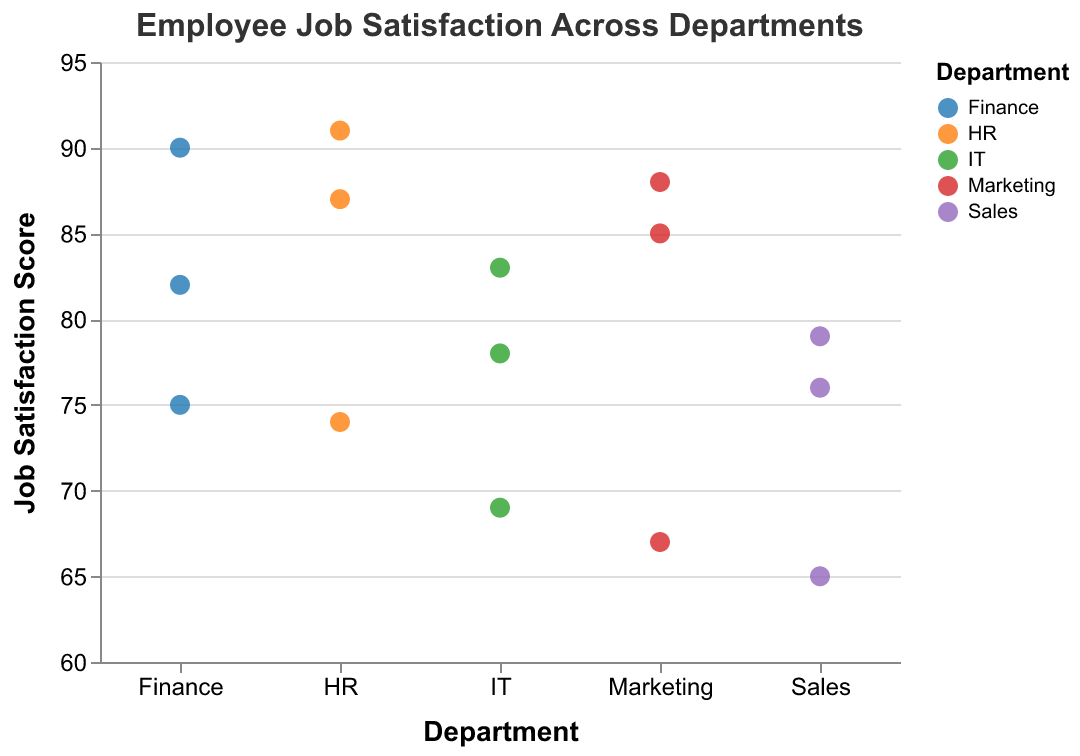What's the title of the figure? The title is located at the top of the plot and reads "Employee Job Satisfaction Across Departments."
Answer: Employee Job Satisfaction Across Departments What are the departments listed along the x-axis? The x-axis lists the departments in a nominal fashion. The departments are Finance, Marketing, IT, HR, and Sales.
Answer: Finance, Marketing, IT, HR, Sales How many employees are there in the IT department? By counting the data points associated with the IT department, there are three employees in IT.
Answer: Three (3) Which department has the highest job satisfaction score, and what is the score? By looking for the highest data point in the y-axis and checking its corresponding department on the x-axis, it can be observed that the HR department has the highest score of 91.
Answer: HR, 91 What is the average job satisfaction score in the Sales department? Summing the job satisfaction scores for the Sales department: 76, 79, and 65, gives a total of 220. Dividing by the number of employees (3) results in an average score of 73.33.
Answer: 73.33 Which employee in the Marketing department has the lowest job satisfaction score? By identifying the lowest point within the Marketing department's data points on the y-axis, it's James Brown with a score of 67.
Answer: James Brown How does the average job satisfaction score of the Finance department compare to that of the HR department? First, calculate the average for the Finance (82, 75, 90) which is (82+75+90)/3 = 82.33. For HR (87, 74, 91) it is (87+74+91)/3 = 84. The HR department's average score (84) is higher than that of the Finance department (82.33).
Answer: HR is higher What is the range of job satisfaction scores in the Marketing department? The range is calculated by subtracting the lowest score from the highest score within the department. For Marketing, the highest score is 88 and the lowest is 67, giving a range of 88 - 67 = 21.
Answer: 21 Are there any departments where all employees have a job satisfaction score above 80? Checking the y-axis values for all data points in each department, the HR department has all employees with scores above 80 (87, 74, 91). The earlier error in questioning should be corrected by noting that William Lewis with 74 prevents a uniform score above 80 across HR. Hence, no department meets the condition.
Answer: No 